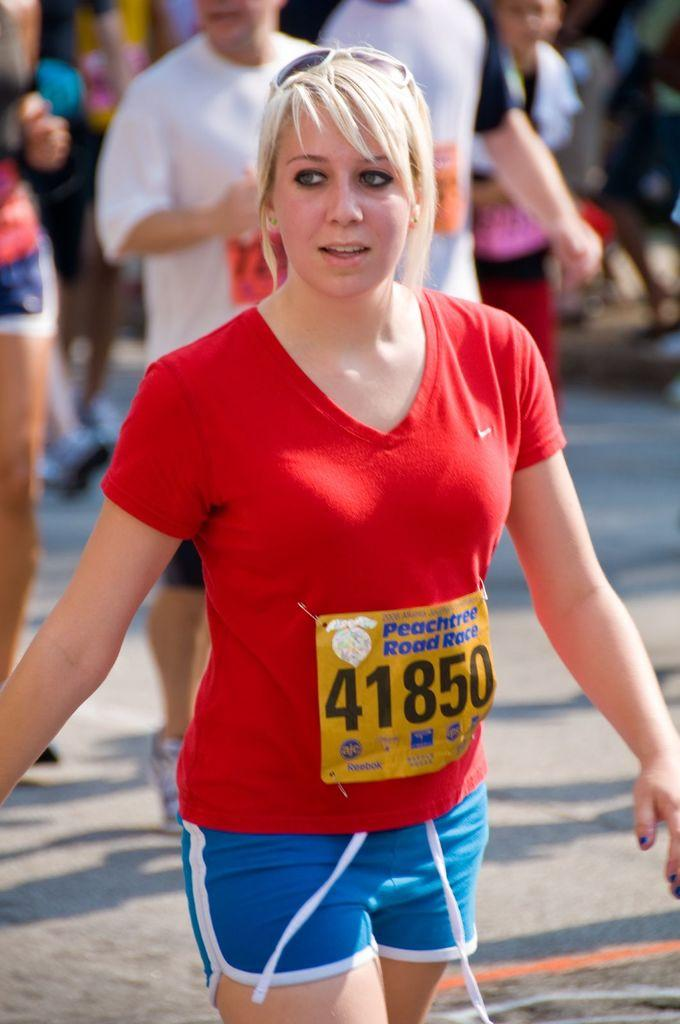<image>
Render a clear and concise summary of the photo. The lady running this race wears the number 41850. 